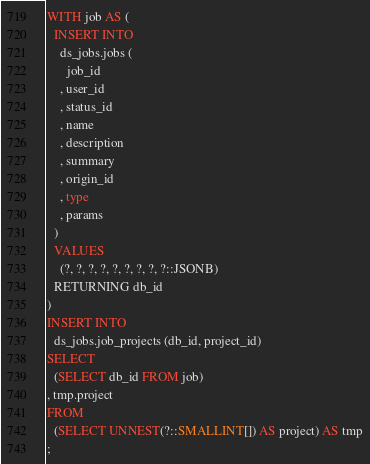<code> <loc_0><loc_0><loc_500><loc_500><_SQL_>WITH job AS (
  INSERT INTO
    ds_jobs.jobs (
      job_id
    , user_id
    , status_id
    , name
    , description
    , summary
    , origin_id
    , type
    , params
  )
  VALUES
    (?, ?, ?, ?, ?, ?, ?, ?, ?::JSONB)
  RETURNING db_id
)
INSERT INTO
  ds_jobs.job_projects (db_id, project_id)
SELECT
  (SELECT db_id FROM job)
, tmp.project
FROM
  (SELECT UNNEST(?::SMALLINT[]) AS project) AS tmp
;
</code> 